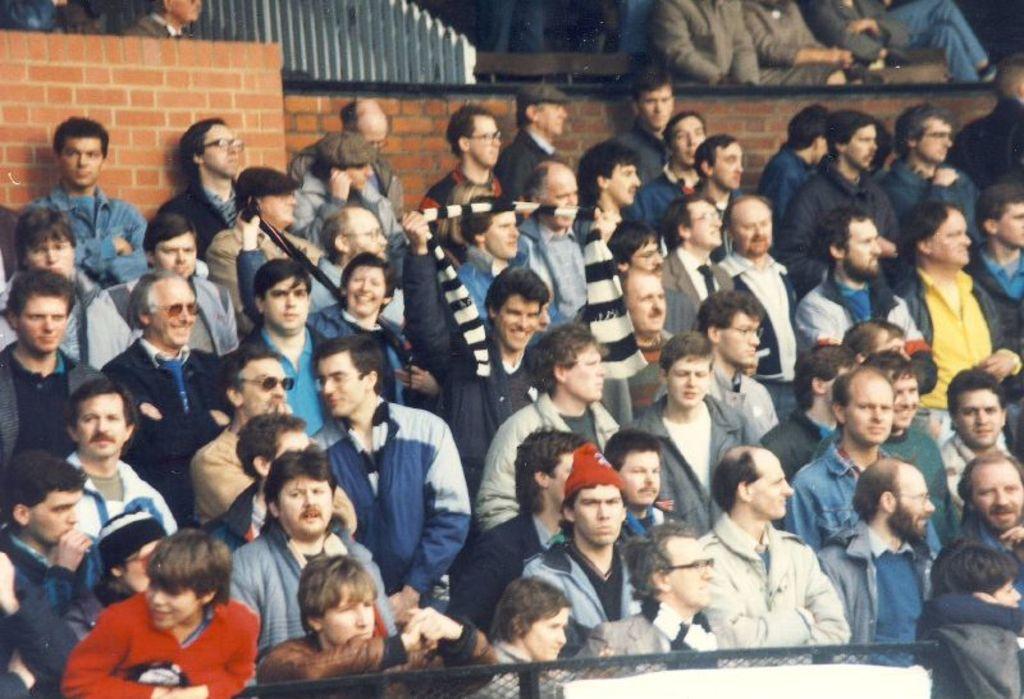Could you give a brief overview of what you see in this image? In this image I can see a group of people standing and facing towards the right. I can see a brick wall behind them. I can see a wooden fence. I can see some more people behind the brick wall. I can see a metal mesh at the bottom of the image. 